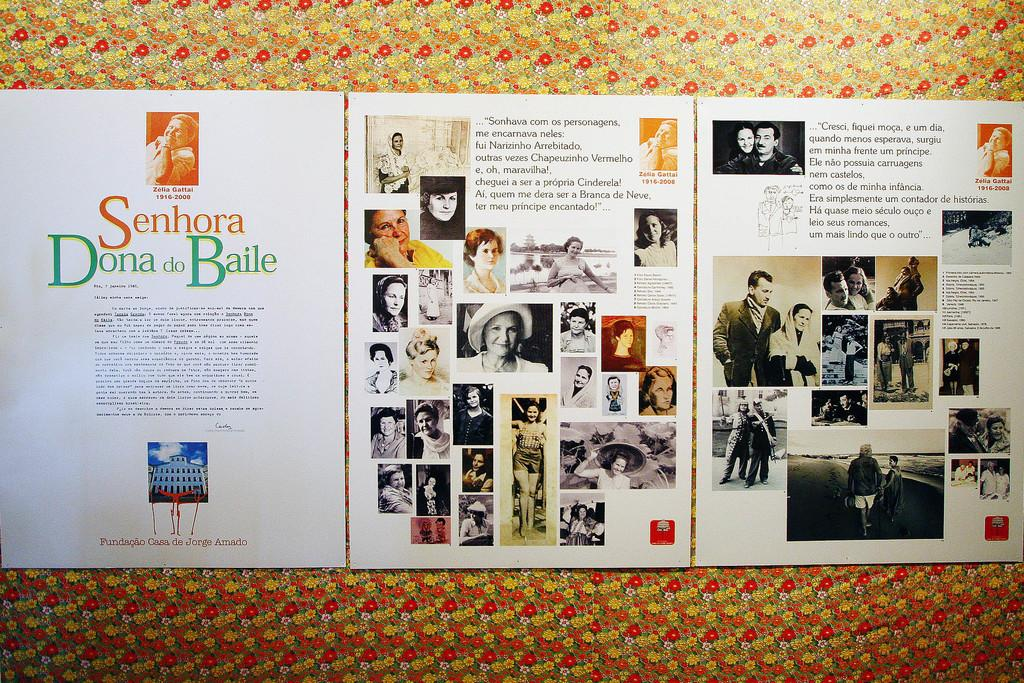<image>
Relay a brief, clear account of the picture shown. Papers posted on a wall that says "Senhora Dona do Baile". 